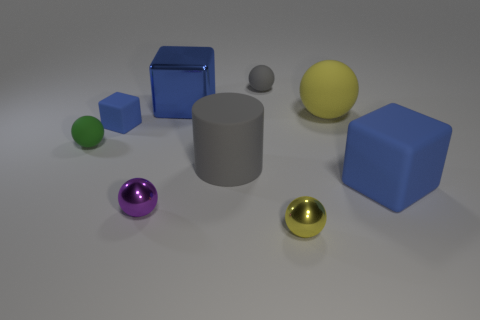Subtract 1 balls. How many balls are left? 4 Subtract all green spheres. How many spheres are left? 4 Subtract all cyan balls. Subtract all red cylinders. How many balls are left? 5 Add 1 yellow rubber things. How many objects exist? 10 Subtract all cylinders. How many objects are left? 8 Subtract 1 gray cylinders. How many objects are left? 8 Subtract all green things. Subtract all small purple shiny things. How many objects are left? 7 Add 7 large yellow spheres. How many large yellow spheres are left? 8 Add 7 purple metal cubes. How many purple metal cubes exist? 7 